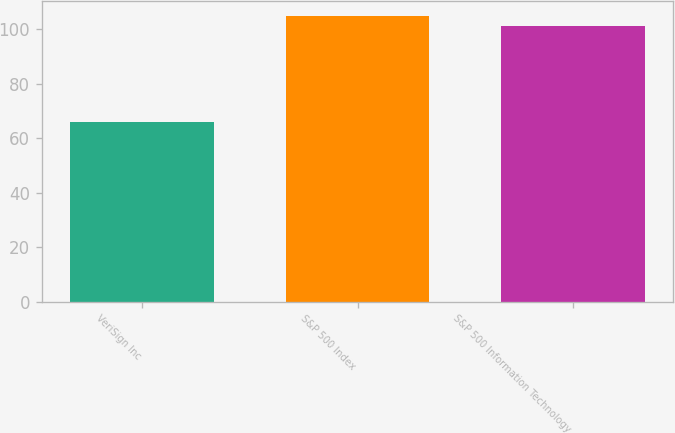Convert chart to OTSL. <chart><loc_0><loc_0><loc_500><loc_500><bar_chart><fcel>VeriSign Inc<fcel>S&P 500 Index<fcel>S&P 500 Information Technology<nl><fcel>66<fcel>105<fcel>101<nl></chart> 